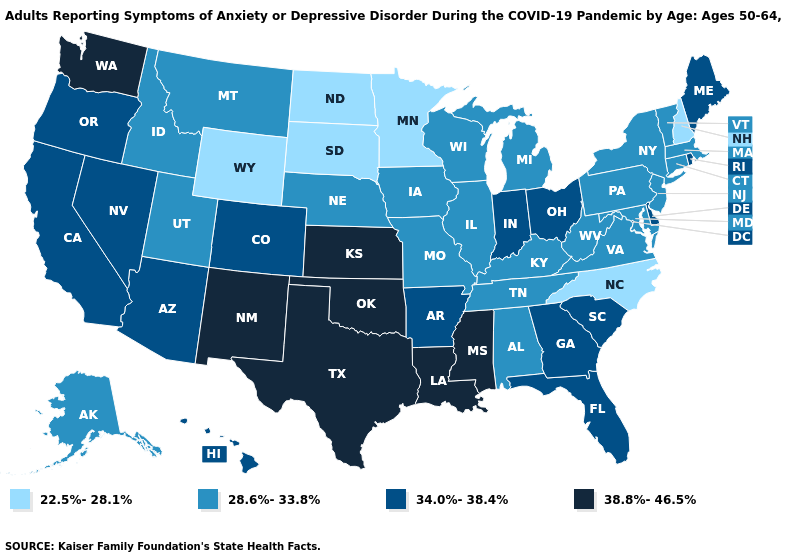What is the lowest value in states that border North Dakota?
Be succinct. 22.5%-28.1%. Does New Hampshire have a lower value than North Carolina?
Short answer required. No. Name the states that have a value in the range 22.5%-28.1%?
Concise answer only. Minnesota, New Hampshire, North Carolina, North Dakota, South Dakota, Wyoming. Does the map have missing data?
Answer briefly. No. Does Colorado have the same value as Arkansas?
Answer briefly. Yes. Does Missouri have a higher value than Wyoming?
Concise answer only. Yes. Name the states that have a value in the range 22.5%-28.1%?
Give a very brief answer. Minnesota, New Hampshire, North Carolina, North Dakota, South Dakota, Wyoming. Does Arkansas have a lower value than Kansas?
Be succinct. Yes. What is the highest value in states that border Colorado?
Be succinct. 38.8%-46.5%. Name the states that have a value in the range 34.0%-38.4%?
Short answer required. Arizona, Arkansas, California, Colorado, Delaware, Florida, Georgia, Hawaii, Indiana, Maine, Nevada, Ohio, Oregon, Rhode Island, South Carolina. How many symbols are there in the legend?
Write a very short answer. 4. Does North Dakota have the lowest value in the USA?
Be succinct. Yes. Which states have the highest value in the USA?
Keep it brief. Kansas, Louisiana, Mississippi, New Mexico, Oklahoma, Texas, Washington. What is the value of Colorado?
Keep it brief. 34.0%-38.4%. Does Washington have the highest value in the USA?
Answer briefly. Yes. 